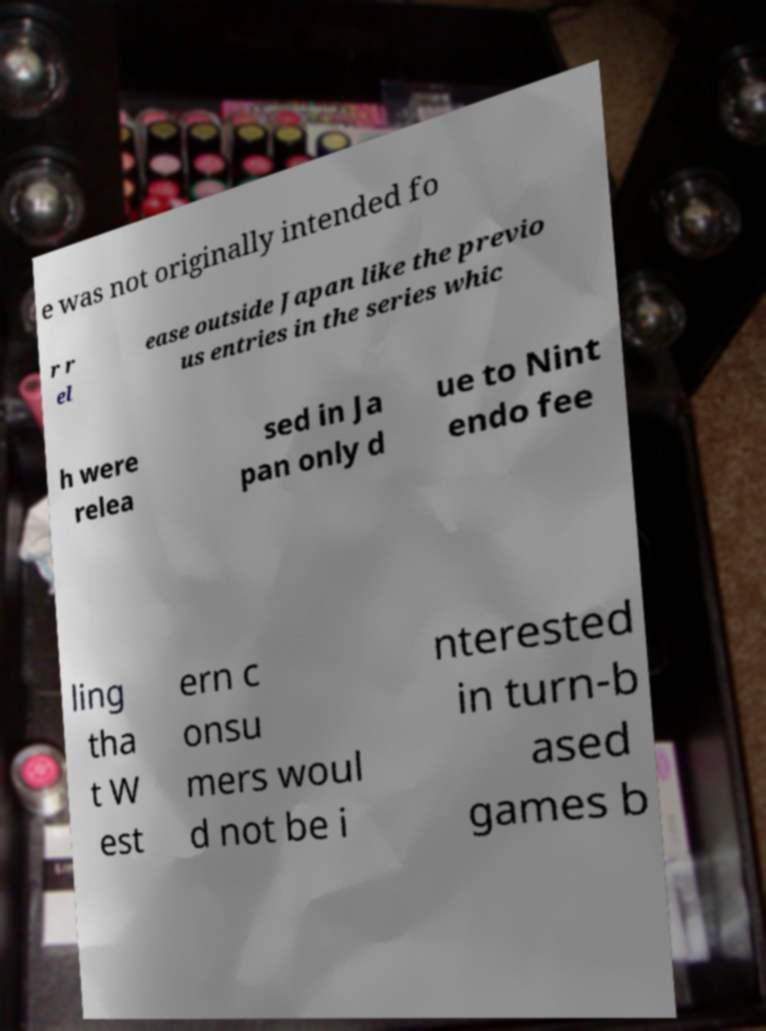Please identify and transcribe the text found in this image. e was not originally intended fo r r el ease outside Japan like the previo us entries in the series whic h were relea sed in Ja pan only d ue to Nint endo fee ling tha t W est ern c onsu mers woul d not be i nterested in turn-b ased games b 